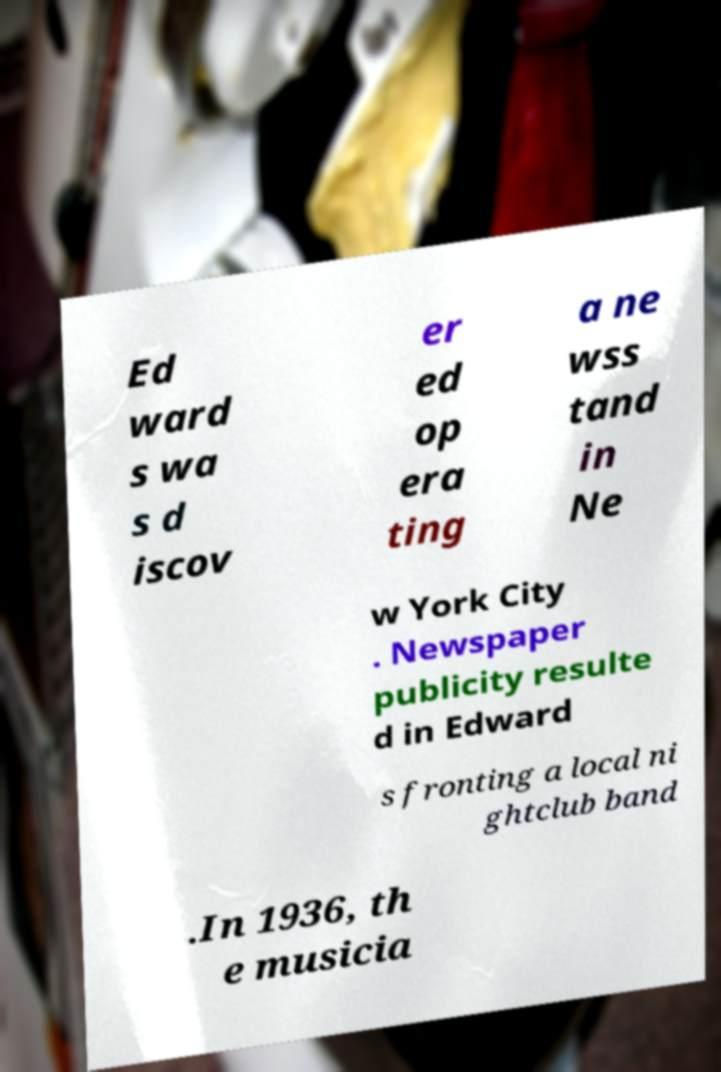Could you assist in decoding the text presented in this image and type it out clearly? Ed ward s wa s d iscov er ed op era ting a ne wss tand in Ne w York City . Newspaper publicity resulte d in Edward s fronting a local ni ghtclub band .In 1936, th e musicia 